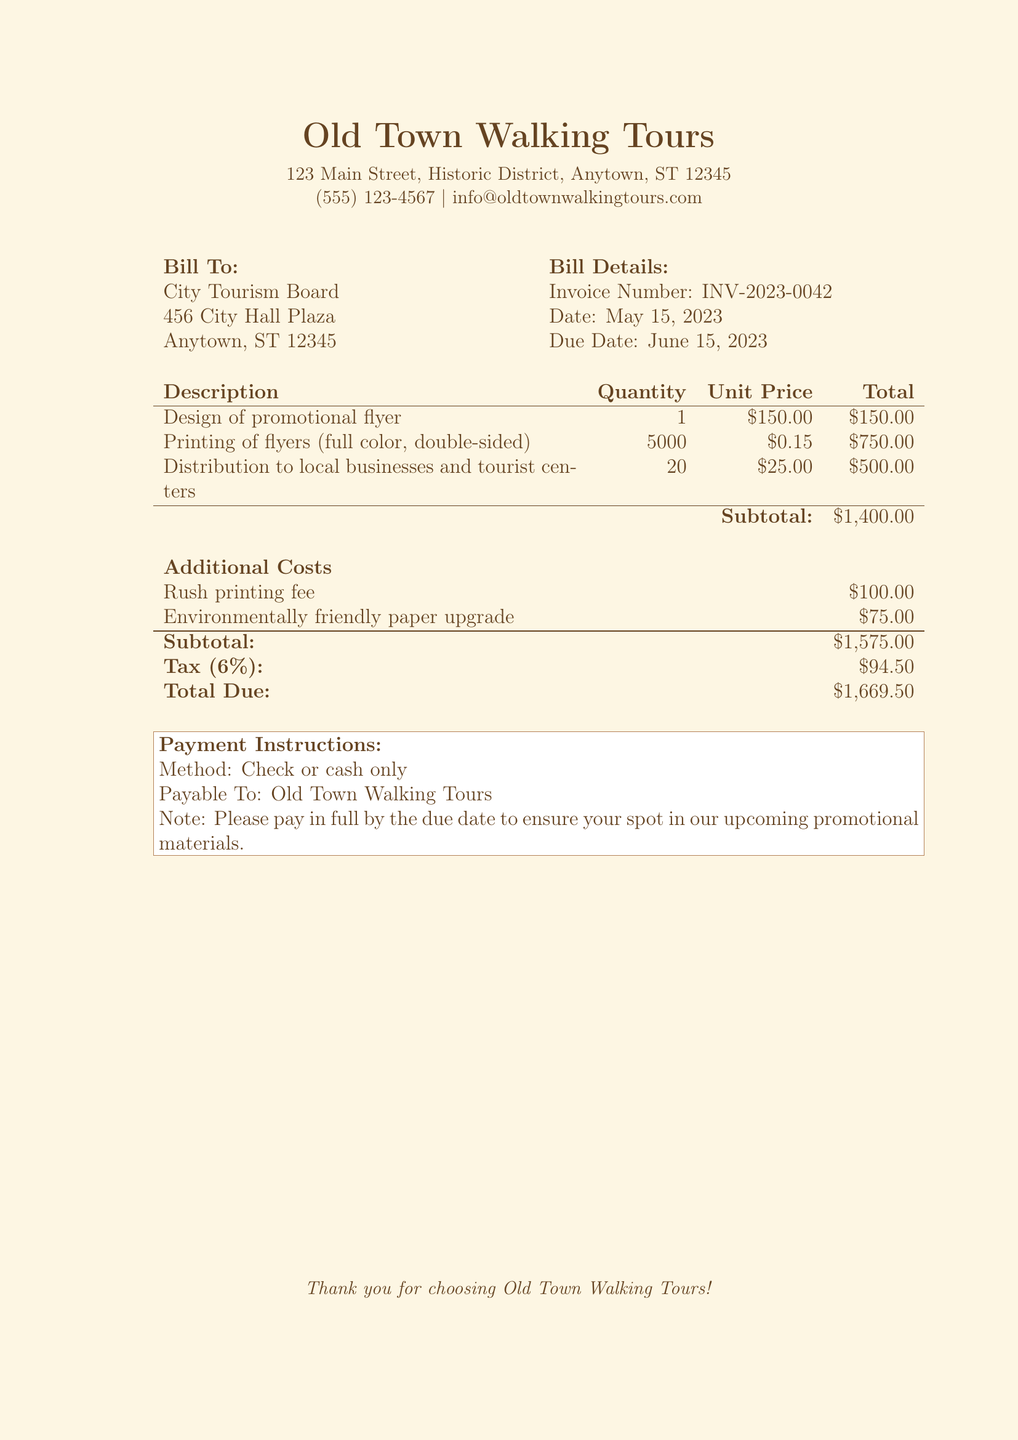What is the invoice number? The invoice number is a unique identifier for the bill, shown in the bill details section.
Answer: INV-2023-0042 What is the total due? The total due is the final amount that needs to be paid, listed at the bottom of the bill.
Answer: $1,669.50 Who is the bill addressed to? The bill is addressed to a specific organization, mentioned at the beginning of the document.
Answer: City Tourism Board What is the rush printing fee? The rush printing fee is an additional charge for expedited service included in the additional costs section.
Answer: $100.00 What is the due date of the invoice? The due date is the deadline for payment indicated in the bill details.
Answer: June 15, 2023 How many flyers were printed? This number indicates how many promotional flyers were printed, mentioned under the printing section.
Answer: 5000 What is the tax rate applied? The tax rate is the percentage used to calculate the tax amount on the subtotal, specified in the additional costs section.
Answer: 6% What method of payment is accepted? The method of payment indicates how the bill can be settled, specified in the payment instructions.
Answer: Check or cash only What is the subtotal before tax? The subtotal before tax is the sum of services and items before tax is added, shown in the additional costs section.
Answer: $1,575.00 